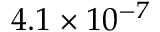Convert formula to latex. <formula><loc_0><loc_0><loc_500><loc_500>4 . 1 \times 1 0 ^ { - 7 }</formula> 